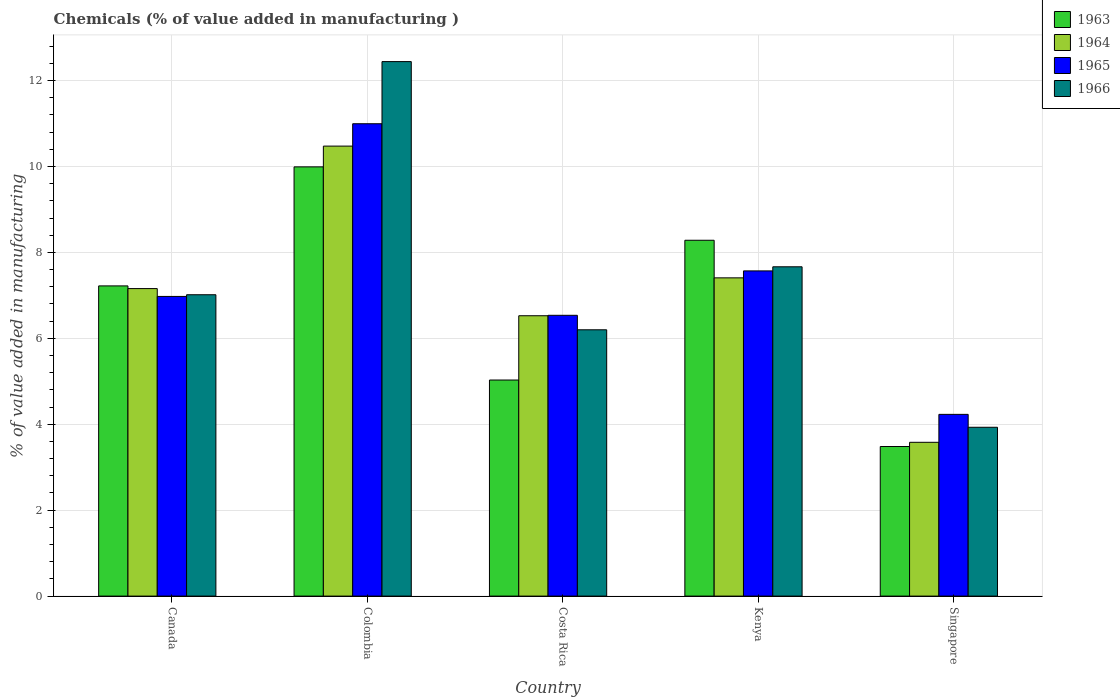Are the number of bars per tick equal to the number of legend labels?
Offer a very short reply. Yes. Are the number of bars on each tick of the X-axis equal?
Your answer should be very brief. Yes. How many bars are there on the 5th tick from the right?
Offer a terse response. 4. In how many cases, is the number of bars for a given country not equal to the number of legend labels?
Make the answer very short. 0. What is the value added in manufacturing chemicals in 1966 in Singapore?
Keep it short and to the point. 3.93. Across all countries, what is the maximum value added in manufacturing chemicals in 1964?
Make the answer very short. 10.47. Across all countries, what is the minimum value added in manufacturing chemicals in 1965?
Ensure brevity in your answer.  4.23. In which country was the value added in manufacturing chemicals in 1965 minimum?
Provide a succinct answer. Singapore. What is the total value added in manufacturing chemicals in 1966 in the graph?
Offer a terse response. 37.25. What is the difference between the value added in manufacturing chemicals in 1963 in Colombia and that in Kenya?
Your answer should be compact. 1.71. What is the difference between the value added in manufacturing chemicals in 1966 in Canada and the value added in manufacturing chemicals in 1965 in Colombia?
Make the answer very short. -3.98. What is the average value added in manufacturing chemicals in 1963 per country?
Provide a short and direct response. 6.8. What is the difference between the value added in manufacturing chemicals of/in 1963 and value added in manufacturing chemicals of/in 1964 in Costa Rica?
Your response must be concise. -1.5. In how many countries, is the value added in manufacturing chemicals in 1964 greater than 12 %?
Make the answer very short. 0. What is the ratio of the value added in manufacturing chemicals in 1965 in Canada to that in Singapore?
Your answer should be compact. 1.65. What is the difference between the highest and the second highest value added in manufacturing chemicals in 1965?
Offer a very short reply. 4.02. What is the difference between the highest and the lowest value added in manufacturing chemicals in 1964?
Give a very brief answer. 6.89. In how many countries, is the value added in manufacturing chemicals in 1963 greater than the average value added in manufacturing chemicals in 1963 taken over all countries?
Ensure brevity in your answer.  3. Is it the case that in every country, the sum of the value added in manufacturing chemicals in 1964 and value added in manufacturing chemicals in 1963 is greater than the sum of value added in manufacturing chemicals in 1966 and value added in manufacturing chemicals in 1965?
Give a very brief answer. No. What does the 3rd bar from the left in Colombia represents?
Offer a terse response. 1965. What does the 4th bar from the right in Costa Rica represents?
Provide a short and direct response. 1963. Is it the case that in every country, the sum of the value added in manufacturing chemicals in 1964 and value added in manufacturing chemicals in 1965 is greater than the value added in manufacturing chemicals in 1966?
Keep it short and to the point. Yes. How many bars are there?
Your answer should be compact. 20. How many countries are there in the graph?
Ensure brevity in your answer.  5. Does the graph contain grids?
Give a very brief answer. Yes. Where does the legend appear in the graph?
Offer a very short reply. Top right. How many legend labels are there?
Your response must be concise. 4. What is the title of the graph?
Ensure brevity in your answer.  Chemicals (% of value added in manufacturing ). What is the label or title of the X-axis?
Offer a terse response. Country. What is the label or title of the Y-axis?
Provide a short and direct response. % of value added in manufacturing. What is the % of value added in manufacturing in 1963 in Canada?
Keep it short and to the point. 7.22. What is the % of value added in manufacturing of 1964 in Canada?
Your answer should be very brief. 7.16. What is the % of value added in manufacturing of 1965 in Canada?
Offer a very short reply. 6.98. What is the % of value added in manufacturing of 1966 in Canada?
Offer a terse response. 7.01. What is the % of value added in manufacturing in 1963 in Colombia?
Your response must be concise. 9.99. What is the % of value added in manufacturing in 1964 in Colombia?
Provide a succinct answer. 10.47. What is the % of value added in manufacturing of 1965 in Colombia?
Your answer should be very brief. 10.99. What is the % of value added in manufacturing in 1966 in Colombia?
Provide a succinct answer. 12.44. What is the % of value added in manufacturing in 1963 in Costa Rica?
Ensure brevity in your answer.  5.03. What is the % of value added in manufacturing of 1964 in Costa Rica?
Ensure brevity in your answer.  6.53. What is the % of value added in manufacturing of 1965 in Costa Rica?
Provide a succinct answer. 6.54. What is the % of value added in manufacturing of 1966 in Costa Rica?
Make the answer very short. 6.2. What is the % of value added in manufacturing of 1963 in Kenya?
Ensure brevity in your answer.  8.28. What is the % of value added in manufacturing of 1964 in Kenya?
Provide a succinct answer. 7.41. What is the % of value added in manufacturing in 1965 in Kenya?
Give a very brief answer. 7.57. What is the % of value added in manufacturing in 1966 in Kenya?
Offer a very short reply. 7.67. What is the % of value added in manufacturing in 1963 in Singapore?
Offer a terse response. 3.48. What is the % of value added in manufacturing in 1964 in Singapore?
Offer a terse response. 3.58. What is the % of value added in manufacturing in 1965 in Singapore?
Offer a very short reply. 4.23. What is the % of value added in manufacturing in 1966 in Singapore?
Offer a terse response. 3.93. Across all countries, what is the maximum % of value added in manufacturing in 1963?
Give a very brief answer. 9.99. Across all countries, what is the maximum % of value added in manufacturing in 1964?
Keep it short and to the point. 10.47. Across all countries, what is the maximum % of value added in manufacturing in 1965?
Give a very brief answer. 10.99. Across all countries, what is the maximum % of value added in manufacturing in 1966?
Your answer should be compact. 12.44. Across all countries, what is the minimum % of value added in manufacturing in 1963?
Offer a terse response. 3.48. Across all countries, what is the minimum % of value added in manufacturing of 1964?
Give a very brief answer. 3.58. Across all countries, what is the minimum % of value added in manufacturing in 1965?
Provide a short and direct response. 4.23. Across all countries, what is the minimum % of value added in manufacturing of 1966?
Your response must be concise. 3.93. What is the total % of value added in manufacturing of 1963 in the graph?
Provide a succinct answer. 34.01. What is the total % of value added in manufacturing of 1964 in the graph?
Your answer should be very brief. 35.15. What is the total % of value added in manufacturing in 1965 in the graph?
Offer a terse response. 36.31. What is the total % of value added in manufacturing in 1966 in the graph?
Provide a short and direct response. 37.25. What is the difference between the % of value added in manufacturing of 1963 in Canada and that in Colombia?
Offer a terse response. -2.77. What is the difference between the % of value added in manufacturing of 1964 in Canada and that in Colombia?
Your answer should be very brief. -3.32. What is the difference between the % of value added in manufacturing of 1965 in Canada and that in Colombia?
Give a very brief answer. -4.02. What is the difference between the % of value added in manufacturing of 1966 in Canada and that in Colombia?
Make the answer very short. -5.43. What is the difference between the % of value added in manufacturing in 1963 in Canada and that in Costa Rica?
Provide a short and direct response. 2.19. What is the difference between the % of value added in manufacturing in 1964 in Canada and that in Costa Rica?
Make the answer very short. 0.63. What is the difference between the % of value added in manufacturing in 1965 in Canada and that in Costa Rica?
Your answer should be very brief. 0.44. What is the difference between the % of value added in manufacturing in 1966 in Canada and that in Costa Rica?
Make the answer very short. 0.82. What is the difference between the % of value added in manufacturing in 1963 in Canada and that in Kenya?
Your response must be concise. -1.06. What is the difference between the % of value added in manufacturing of 1964 in Canada and that in Kenya?
Your answer should be very brief. -0.25. What is the difference between the % of value added in manufacturing in 1965 in Canada and that in Kenya?
Your answer should be compact. -0.59. What is the difference between the % of value added in manufacturing in 1966 in Canada and that in Kenya?
Provide a succinct answer. -0.65. What is the difference between the % of value added in manufacturing in 1963 in Canada and that in Singapore?
Make the answer very short. 3.74. What is the difference between the % of value added in manufacturing in 1964 in Canada and that in Singapore?
Offer a very short reply. 3.58. What is the difference between the % of value added in manufacturing of 1965 in Canada and that in Singapore?
Your answer should be compact. 2.75. What is the difference between the % of value added in manufacturing in 1966 in Canada and that in Singapore?
Provide a succinct answer. 3.08. What is the difference between the % of value added in manufacturing in 1963 in Colombia and that in Costa Rica?
Offer a terse response. 4.96. What is the difference between the % of value added in manufacturing of 1964 in Colombia and that in Costa Rica?
Offer a very short reply. 3.95. What is the difference between the % of value added in manufacturing in 1965 in Colombia and that in Costa Rica?
Your answer should be very brief. 4.46. What is the difference between the % of value added in manufacturing in 1966 in Colombia and that in Costa Rica?
Provide a short and direct response. 6.24. What is the difference between the % of value added in manufacturing in 1963 in Colombia and that in Kenya?
Give a very brief answer. 1.71. What is the difference between the % of value added in manufacturing in 1964 in Colombia and that in Kenya?
Provide a succinct answer. 3.07. What is the difference between the % of value added in manufacturing of 1965 in Colombia and that in Kenya?
Give a very brief answer. 3.43. What is the difference between the % of value added in manufacturing of 1966 in Colombia and that in Kenya?
Keep it short and to the point. 4.78. What is the difference between the % of value added in manufacturing of 1963 in Colombia and that in Singapore?
Ensure brevity in your answer.  6.51. What is the difference between the % of value added in manufacturing of 1964 in Colombia and that in Singapore?
Your answer should be compact. 6.89. What is the difference between the % of value added in manufacturing of 1965 in Colombia and that in Singapore?
Your answer should be very brief. 6.76. What is the difference between the % of value added in manufacturing in 1966 in Colombia and that in Singapore?
Provide a short and direct response. 8.51. What is the difference between the % of value added in manufacturing of 1963 in Costa Rica and that in Kenya?
Ensure brevity in your answer.  -3.25. What is the difference between the % of value added in manufacturing of 1964 in Costa Rica and that in Kenya?
Provide a short and direct response. -0.88. What is the difference between the % of value added in manufacturing of 1965 in Costa Rica and that in Kenya?
Offer a very short reply. -1.03. What is the difference between the % of value added in manufacturing of 1966 in Costa Rica and that in Kenya?
Your response must be concise. -1.47. What is the difference between the % of value added in manufacturing of 1963 in Costa Rica and that in Singapore?
Make the answer very short. 1.55. What is the difference between the % of value added in manufacturing of 1964 in Costa Rica and that in Singapore?
Ensure brevity in your answer.  2.95. What is the difference between the % of value added in manufacturing of 1965 in Costa Rica and that in Singapore?
Keep it short and to the point. 2.31. What is the difference between the % of value added in manufacturing of 1966 in Costa Rica and that in Singapore?
Provide a short and direct response. 2.27. What is the difference between the % of value added in manufacturing in 1963 in Kenya and that in Singapore?
Keep it short and to the point. 4.8. What is the difference between the % of value added in manufacturing of 1964 in Kenya and that in Singapore?
Keep it short and to the point. 3.83. What is the difference between the % of value added in manufacturing in 1965 in Kenya and that in Singapore?
Make the answer very short. 3.34. What is the difference between the % of value added in manufacturing of 1966 in Kenya and that in Singapore?
Provide a succinct answer. 3.74. What is the difference between the % of value added in manufacturing of 1963 in Canada and the % of value added in manufacturing of 1964 in Colombia?
Your response must be concise. -3.25. What is the difference between the % of value added in manufacturing in 1963 in Canada and the % of value added in manufacturing in 1965 in Colombia?
Offer a very short reply. -3.77. What is the difference between the % of value added in manufacturing of 1963 in Canada and the % of value added in manufacturing of 1966 in Colombia?
Keep it short and to the point. -5.22. What is the difference between the % of value added in manufacturing in 1964 in Canada and the % of value added in manufacturing in 1965 in Colombia?
Ensure brevity in your answer.  -3.84. What is the difference between the % of value added in manufacturing of 1964 in Canada and the % of value added in manufacturing of 1966 in Colombia?
Your answer should be very brief. -5.28. What is the difference between the % of value added in manufacturing of 1965 in Canada and the % of value added in manufacturing of 1966 in Colombia?
Offer a very short reply. -5.47. What is the difference between the % of value added in manufacturing in 1963 in Canada and the % of value added in manufacturing in 1964 in Costa Rica?
Offer a terse response. 0.69. What is the difference between the % of value added in manufacturing of 1963 in Canada and the % of value added in manufacturing of 1965 in Costa Rica?
Give a very brief answer. 0.68. What is the difference between the % of value added in manufacturing in 1963 in Canada and the % of value added in manufacturing in 1966 in Costa Rica?
Your answer should be very brief. 1.02. What is the difference between the % of value added in manufacturing in 1964 in Canada and the % of value added in manufacturing in 1965 in Costa Rica?
Ensure brevity in your answer.  0.62. What is the difference between the % of value added in manufacturing of 1964 in Canada and the % of value added in manufacturing of 1966 in Costa Rica?
Make the answer very short. 0.96. What is the difference between the % of value added in manufacturing in 1965 in Canada and the % of value added in manufacturing in 1966 in Costa Rica?
Offer a terse response. 0.78. What is the difference between the % of value added in manufacturing in 1963 in Canada and the % of value added in manufacturing in 1964 in Kenya?
Your response must be concise. -0.19. What is the difference between the % of value added in manufacturing in 1963 in Canada and the % of value added in manufacturing in 1965 in Kenya?
Keep it short and to the point. -0.35. What is the difference between the % of value added in manufacturing in 1963 in Canada and the % of value added in manufacturing in 1966 in Kenya?
Make the answer very short. -0.44. What is the difference between the % of value added in manufacturing of 1964 in Canada and the % of value added in manufacturing of 1965 in Kenya?
Ensure brevity in your answer.  -0.41. What is the difference between the % of value added in manufacturing in 1964 in Canada and the % of value added in manufacturing in 1966 in Kenya?
Your answer should be very brief. -0.51. What is the difference between the % of value added in manufacturing of 1965 in Canada and the % of value added in manufacturing of 1966 in Kenya?
Offer a very short reply. -0.69. What is the difference between the % of value added in manufacturing in 1963 in Canada and the % of value added in manufacturing in 1964 in Singapore?
Offer a very short reply. 3.64. What is the difference between the % of value added in manufacturing in 1963 in Canada and the % of value added in manufacturing in 1965 in Singapore?
Offer a very short reply. 2.99. What is the difference between the % of value added in manufacturing of 1963 in Canada and the % of value added in manufacturing of 1966 in Singapore?
Your answer should be very brief. 3.29. What is the difference between the % of value added in manufacturing in 1964 in Canada and the % of value added in manufacturing in 1965 in Singapore?
Your answer should be very brief. 2.93. What is the difference between the % of value added in manufacturing of 1964 in Canada and the % of value added in manufacturing of 1966 in Singapore?
Your response must be concise. 3.23. What is the difference between the % of value added in manufacturing in 1965 in Canada and the % of value added in manufacturing in 1966 in Singapore?
Keep it short and to the point. 3.05. What is the difference between the % of value added in manufacturing of 1963 in Colombia and the % of value added in manufacturing of 1964 in Costa Rica?
Your answer should be very brief. 3.47. What is the difference between the % of value added in manufacturing of 1963 in Colombia and the % of value added in manufacturing of 1965 in Costa Rica?
Offer a very short reply. 3.46. What is the difference between the % of value added in manufacturing in 1963 in Colombia and the % of value added in manufacturing in 1966 in Costa Rica?
Make the answer very short. 3.79. What is the difference between the % of value added in manufacturing of 1964 in Colombia and the % of value added in manufacturing of 1965 in Costa Rica?
Your answer should be compact. 3.94. What is the difference between the % of value added in manufacturing in 1964 in Colombia and the % of value added in manufacturing in 1966 in Costa Rica?
Your answer should be compact. 4.28. What is the difference between the % of value added in manufacturing of 1965 in Colombia and the % of value added in manufacturing of 1966 in Costa Rica?
Offer a very short reply. 4.8. What is the difference between the % of value added in manufacturing in 1963 in Colombia and the % of value added in manufacturing in 1964 in Kenya?
Your answer should be compact. 2.58. What is the difference between the % of value added in manufacturing of 1963 in Colombia and the % of value added in manufacturing of 1965 in Kenya?
Give a very brief answer. 2.42. What is the difference between the % of value added in manufacturing of 1963 in Colombia and the % of value added in manufacturing of 1966 in Kenya?
Your answer should be very brief. 2.33. What is the difference between the % of value added in manufacturing in 1964 in Colombia and the % of value added in manufacturing in 1965 in Kenya?
Keep it short and to the point. 2.9. What is the difference between the % of value added in manufacturing of 1964 in Colombia and the % of value added in manufacturing of 1966 in Kenya?
Offer a very short reply. 2.81. What is the difference between the % of value added in manufacturing in 1965 in Colombia and the % of value added in manufacturing in 1966 in Kenya?
Offer a terse response. 3.33. What is the difference between the % of value added in manufacturing of 1963 in Colombia and the % of value added in manufacturing of 1964 in Singapore?
Make the answer very short. 6.41. What is the difference between the % of value added in manufacturing in 1963 in Colombia and the % of value added in manufacturing in 1965 in Singapore?
Offer a terse response. 5.76. What is the difference between the % of value added in manufacturing in 1963 in Colombia and the % of value added in manufacturing in 1966 in Singapore?
Provide a short and direct response. 6.06. What is the difference between the % of value added in manufacturing in 1964 in Colombia and the % of value added in manufacturing in 1965 in Singapore?
Offer a very short reply. 6.24. What is the difference between the % of value added in manufacturing of 1964 in Colombia and the % of value added in manufacturing of 1966 in Singapore?
Offer a very short reply. 6.54. What is the difference between the % of value added in manufacturing of 1965 in Colombia and the % of value added in manufacturing of 1966 in Singapore?
Ensure brevity in your answer.  7.07. What is the difference between the % of value added in manufacturing of 1963 in Costa Rica and the % of value added in manufacturing of 1964 in Kenya?
Offer a very short reply. -2.38. What is the difference between the % of value added in manufacturing of 1963 in Costa Rica and the % of value added in manufacturing of 1965 in Kenya?
Your answer should be compact. -2.54. What is the difference between the % of value added in manufacturing in 1963 in Costa Rica and the % of value added in manufacturing in 1966 in Kenya?
Provide a short and direct response. -2.64. What is the difference between the % of value added in manufacturing of 1964 in Costa Rica and the % of value added in manufacturing of 1965 in Kenya?
Your answer should be very brief. -1.04. What is the difference between the % of value added in manufacturing in 1964 in Costa Rica and the % of value added in manufacturing in 1966 in Kenya?
Make the answer very short. -1.14. What is the difference between the % of value added in manufacturing of 1965 in Costa Rica and the % of value added in manufacturing of 1966 in Kenya?
Keep it short and to the point. -1.13. What is the difference between the % of value added in manufacturing in 1963 in Costa Rica and the % of value added in manufacturing in 1964 in Singapore?
Offer a very short reply. 1.45. What is the difference between the % of value added in manufacturing in 1963 in Costa Rica and the % of value added in manufacturing in 1965 in Singapore?
Provide a short and direct response. 0.8. What is the difference between the % of value added in manufacturing of 1963 in Costa Rica and the % of value added in manufacturing of 1966 in Singapore?
Offer a terse response. 1.1. What is the difference between the % of value added in manufacturing in 1964 in Costa Rica and the % of value added in manufacturing in 1965 in Singapore?
Ensure brevity in your answer.  2.3. What is the difference between the % of value added in manufacturing in 1964 in Costa Rica and the % of value added in manufacturing in 1966 in Singapore?
Provide a succinct answer. 2.6. What is the difference between the % of value added in manufacturing of 1965 in Costa Rica and the % of value added in manufacturing of 1966 in Singapore?
Your response must be concise. 2.61. What is the difference between the % of value added in manufacturing of 1963 in Kenya and the % of value added in manufacturing of 1964 in Singapore?
Your answer should be very brief. 4.7. What is the difference between the % of value added in manufacturing of 1963 in Kenya and the % of value added in manufacturing of 1965 in Singapore?
Your answer should be very brief. 4.05. What is the difference between the % of value added in manufacturing of 1963 in Kenya and the % of value added in manufacturing of 1966 in Singapore?
Your response must be concise. 4.35. What is the difference between the % of value added in manufacturing in 1964 in Kenya and the % of value added in manufacturing in 1965 in Singapore?
Provide a succinct answer. 3.18. What is the difference between the % of value added in manufacturing of 1964 in Kenya and the % of value added in manufacturing of 1966 in Singapore?
Your answer should be very brief. 3.48. What is the difference between the % of value added in manufacturing of 1965 in Kenya and the % of value added in manufacturing of 1966 in Singapore?
Offer a very short reply. 3.64. What is the average % of value added in manufacturing in 1963 per country?
Your answer should be compact. 6.8. What is the average % of value added in manufacturing of 1964 per country?
Provide a succinct answer. 7.03. What is the average % of value added in manufacturing in 1965 per country?
Offer a terse response. 7.26. What is the average % of value added in manufacturing in 1966 per country?
Ensure brevity in your answer.  7.45. What is the difference between the % of value added in manufacturing in 1963 and % of value added in manufacturing in 1964 in Canada?
Give a very brief answer. 0.06. What is the difference between the % of value added in manufacturing of 1963 and % of value added in manufacturing of 1965 in Canada?
Your answer should be compact. 0.25. What is the difference between the % of value added in manufacturing of 1963 and % of value added in manufacturing of 1966 in Canada?
Offer a terse response. 0.21. What is the difference between the % of value added in manufacturing in 1964 and % of value added in manufacturing in 1965 in Canada?
Provide a short and direct response. 0.18. What is the difference between the % of value added in manufacturing in 1964 and % of value added in manufacturing in 1966 in Canada?
Offer a terse response. 0.14. What is the difference between the % of value added in manufacturing of 1965 and % of value added in manufacturing of 1966 in Canada?
Your response must be concise. -0.04. What is the difference between the % of value added in manufacturing in 1963 and % of value added in manufacturing in 1964 in Colombia?
Keep it short and to the point. -0.48. What is the difference between the % of value added in manufacturing of 1963 and % of value added in manufacturing of 1965 in Colombia?
Your answer should be very brief. -1. What is the difference between the % of value added in manufacturing in 1963 and % of value added in manufacturing in 1966 in Colombia?
Give a very brief answer. -2.45. What is the difference between the % of value added in manufacturing in 1964 and % of value added in manufacturing in 1965 in Colombia?
Make the answer very short. -0.52. What is the difference between the % of value added in manufacturing in 1964 and % of value added in manufacturing in 1966 in Colombia?
Your answer should be very brief. -1.97. What is the difference between the % of value added in manufacturing in 1965 and % of value added in manufacturing in 1966 in Colombia?
Your answer should be compact. -1.45. What is the difference between the % of value added in manufacturing in 1963 and % of value added in manufacturing in 1964 in Costa Rica?
Provide a succinct answer. -1.5. What is the difference between the % of value added in manufacturing of 1963 and % of value added in manufacturing of 1965 in Costa Rica?
Keep it short and to the point. -1.51. What is the difference between the % of value added in manufacturing of 1963 and % of value added in manufacturing of 1966 in Costa Rica?
Your answer should be compact. -1.17. What is the difference between the % of value added in manufacturing in 1964 and % of value added in manufacturing in 1965 in Costa Rica?
Ensure brevity in your answer.  -0.01. What is the difference between the % of value added in manufacturing in 1964 and % of value added in manufacturing in 1966 in Costa Rica?
Ensure brevity in your answer.  0.33. What is the difference between the % of value added in manufacturing in 1965 and % of value added in manufacturing in 1966 in Costa Rica?
Make the answer very short. 0.34. What is the difference between the % of value added in manufacturing of 1963 and % of value added in manufacturing of 1964 in Kenya?
Keep it short and to the point. 0.87. What is the difference between the % of value added in manufacturing in 1963 and % of value added in manufacturing in 1965 in Kenya?
Offer a terse response. 0.71. What is the difference between the % of value added in manufacturing of 1963 and % of value added in manufacturing of 1966 in Kenya?
Provide a short and direct response. 0.62. What is the difference between the % of value added in manufacturing of 1964 and % of value added in manufacturing of 1965 in Kenya?
Your answer should be very brief. -0.16. What is the difference between the % of value added in manufacturing of 1964 and % of value added in manufacturing of 1966 in Kenya?
Ensure brevity in your answer.  -0.26. What is the difference between the % of value added in manufacturing of 1965 and % of value added in manufacturing of 1966 in Kenya?
Your answer should be compact. -0.1. What is the difference between the % of value added in manufacturing in 1963 and % of value added in manufacturing in 1964 in Singapore?
Offer a terse response. -0.1. What is the difference between the % of value added in manufacturing of 1963 and % of value added in manufacturing of 1965 in Singapore?
Provide a short and direct response. -0.75. What is the difference between the % of value added in manufacturing of 1963 and % of value added in manufacturing of 1966 in Singapore?
Provide a short and direct response. -0.45. What is the difference between the % of value added in manufacturing of 1964 and % of value added in manufacturing of 1965 in Singapore?
Provide a succinct answer. -0.65. What is the difference between the % of value added in manufacturing in 1964 and % of value added in manufacturing in 1966 in Singapore?
Provide a short and direct response. -0.35. What is the difference between the % of value added in manufacturing of 1965 and % of value added in manufacturing of 1966 in Singapore?
Your answer should be very brief. 0.3. What is the ratio of the % of value added in manufacturing of 1963 in Canada to that in Colombia?
Ensure brevity in your answer.  0.72. What is the ratio of the % of value added in manufacturing of 1964 in Canada to that in Colombia?
Your response must be concise. 0.68. What is the ratio of the % of value added in manufacturing of 1965 in Canada to that in Colombia?
Keep it short and to the point. 0.63. What is the ratio of the % of value added in manufacturing in 1966 in Canada to that in Colombia?
Your response must be concise. 0.56. What is the ratio of the % of value added in manufacturing of 1963 in Canada to that in Costa Rica?
Provide a short and direct response. 1.44. What is the ratio of the % of value added in manufacturing in 1964 in Canada to that in Costa Rica?
Provide a short and direct response. 1.1. What is the ratio of the % of value added in manufacturing in 1965 in Canada to that in Costa Rica?
Offer a very short reply. 1.07. What is the ratio of the % of value added in manufacturing in 1966 in Canada to that in Costa Rica?
Ensure brevity in your answer.  1.13. What is the ratio of the % of value added in manufacturing of 1963 in Canada to that in Kenya?
Offer a very short reply. 0.87. What is the ratio of the % of value added in manufacturing in 1964 in Canada to that in Kenya?
Provide a succinct answer. 0.97. What is the ratio of the % of value added in manufacturing in 1965 in Canada to that in Kenya?
Offer a terse response. 0.92. What is the ratio of the % of value added in manufacturing of 1966 in Canada to that in Kenya?
Your response must be concise. 0.92. What is the ratio of the % of value added in manufacturing in 1963 in Canada to that in Singapore?
Give a very brief answer. 2.07. What is the ratio of the % of value added in manufacturing of 1964 in Canada to that in Singapore?
Your answer should be very brief. 2. What is the ratio of the % of value added in manufacturing of 1965 in Canada to that in Singapore?
Your answer should be compact. 1.65. What is the ratio of the % of value added in manufacturing in 1966 in Canada to that in Singapore?
Ensure brevity in your answer.  1.78. What is the ratio of the % of value added in manufacturing in 1963 in Colombia to that in Costa Rica?
Provide a short and direct response. 1.99. What is the ratio of the % of value added in manufacturing in 1964 in Colombia to that in Costa Rica?
Keep it short and to the point. 1.61. What is the ratio of the % of value added in manufacturing of 1965 in Colombia to that in Costa Rica?
Ensure brevity in your answer.  1.68. What is the ratio of the % of value added in manufacturing in 1966 in Colombia to that in Costa Rica?
Offer a very short reply. 2.01. What is the ratio of the % of value added in manufacturing in 1963 in Colombia to that in Kenya?
Your response must be concise. 1.21. What is the ratio of the % of value added in manufacturing in 1964 in Colombia to that in Kenya?
Your answer should be compact. 1.41. What is the ratio of the % of value added in manufacturing of 1965 in Colombia to that in Kenya?
Your response must be concise. 1.45. What is the ratio of the % of value added in manufacturing of 1966 in Colombia to that in Kenya?
Ensure brevity in your answer.  1.62. What is the ratio of the % of value added in manufacturing in 1963 in Colombia to that in Singapore?
Offer a very short reply. 2.87. What is the ratio of the % of value added in manufacturing of 1964 in Colombia to that in Singapore?
Keep it short and to the point. 2.93. What is the ratio of the % of value added in manufacturing of 1965 in Colombia to that in Singapore?
Make the answer very short. 2.6. What is the ratio of the % of value added in manufacturing in 1966 in Colombia to that in Singapore?
Make the answer very short. 3.17. What is the ratio of the % of value added in manufacturing of 1963 in Costa Rica to that in Kenya?
Keep it short and to the point. 0.61. What is the ratio of the % of value added in manufacturing in 1964 in Costa Rica to that in Kenya?
Make the answer very short. 0.88. What is the ratio of the % of value added in manufacturing of 1965 in Costa Rica to that in Kenya?
Give a very brief answer. 0.86. What is the ratio of the % of value added in manufacturing of 1966 in Costa Rica to that in Kenya?
Your answer should be compact. 0.81. What is the ratio of the % of value added in manufacturing in 1963 in Costa Rica to that in Singapore?
Ensure brevity in your answer.  1.44. What is the ratio of the % of value added in manufacturing in 1964 in Costa Rica to that in Singapore?
Provide a short and direct response. 1.82. What is the ratio of the % of value added in manufacturing in 1965 in Costa Rica to that in Singapore?
Your answer should be compact. 1.55. What is the ratio of the % of value added in manufacturing of 1966 in Costa Rica to that in Singapore?
Ensure brevity in your answer.  1.58. What is the ratio of the % of value added in manufacturing of 1963 in Kenya to that in Singapore?
Offer a terse response. 2.38. What is the ratio of the % of value added in manufacturing in 1964 in Kenya to that in Singapore?
Give a very brief answer. 2.07. What is the ratio of the % of value added in manufacturing in 1965 in Kenya to that in Singapore?
Keep it short and to the point. 1.79. What is the ratio of the % of value added in manufacturing in 1966 in Kenya to that in Singapore?
Give a very brief answer. 1.95. What is the difference between the highest and the second highest % of value added in manufacturing of 1963?
Provide a short and direct response. 1.71. What is the difference between the highest and the second highest % of value added in manufacturing of 1964?
Offer a very short reply. 3.07. What is the difference between the highest and the second highest % of value added in manufacturing of 1965?
Ensure brevity in your answer.  3.43. What is the difference between the highest and the second highest % of value added in manufacturing in 1966?
Give a very brief answer. 4.78. What is the difference between the highest and the lowest % of value added in manufacturing of 1963?
Your answer should be very brief. 6.51. What is the difference between the highest and the lowest % of value added in manufacturing of 1964?
Offer a very short reply. 6.89. What is the difference between the highest and the lowest % of value added in manufacturing in 1965?
Provide a succinct answer. 6.76. What is the difference between the highest and the lowest % of value added in manufacturing in 1966?
Offer a very short reply. 8.51. 